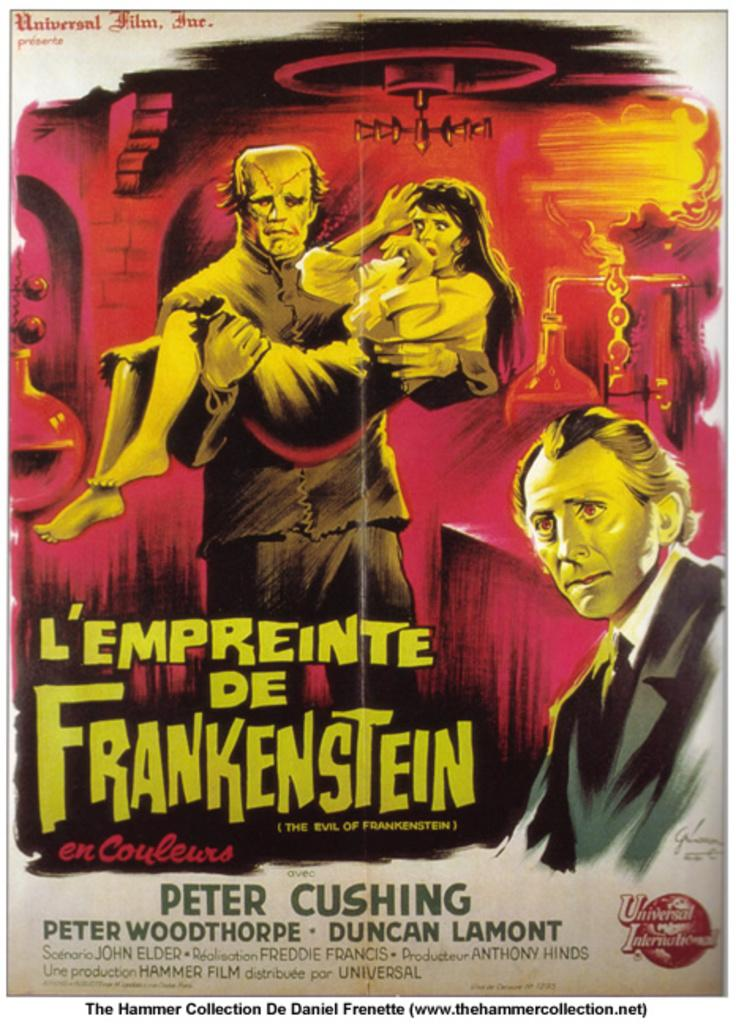<image>
Write a terse but informative summary of the picture. Poster that shows a frankenstein holding a woman with the name "Peter Cushing". 